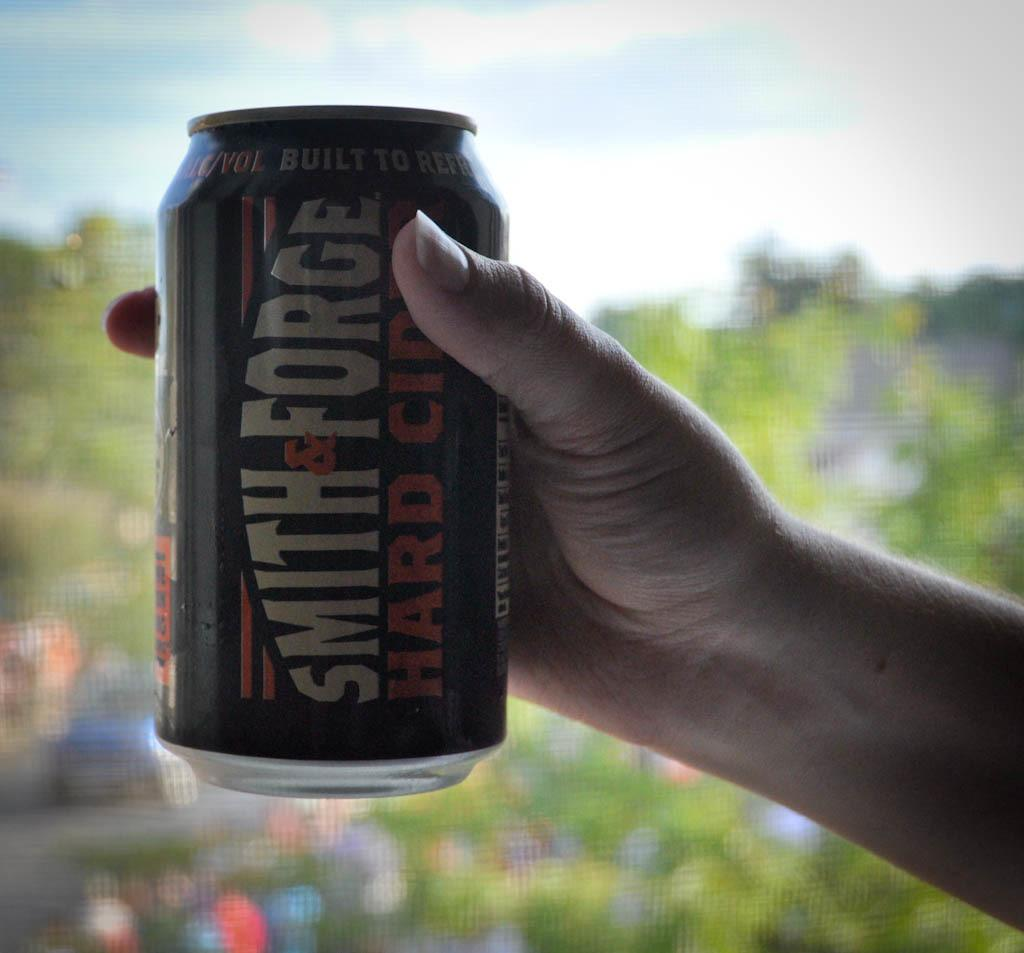<image>
Relay a brief, clear account of the picture shown. A hand holding a smith and forge hard cider drink. 